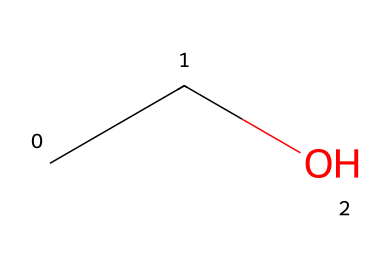What is the name of this chemical? The given SMILES representation "CCO" corresponds to ethanol, a common alcohol. The structure reveals two carbon atoms and one hydroxyl group, which identifies it as ethanol.
Answer: ethanol How many carbon atoms are present in this molecule? By analyzing the SMILES "CCO," we see "CC," which indicates 2 carbon atoms.
Answer: 2 What functional group does this molecule contain? The "O" at the end of "CCO" indicates the presence of a hydroxyl group (-OH), which is characteristic of alcohols like ethanol.
Answer: hydroxyl What is the molecular formula of this compound? From the structure "CCO," we can count 2 carbons (C), 6 hydrogens (H) suggested from the complete structure, and 1 oxygen (O), leading to the molecular formula C2H6O.
Answer: C2H6O What type of bonding is predominantly present in ethanol? Ethanol exhibits covalent bonding, as seen from the connections between carbon, oxygen, and hydrogen atoms in its structure.
Answer: covalent Is this molecule polar or nonpolar? The presence of the hydroxyl group (-OH) introduces a polar feature due to the electronegativity difference between oxygen and hydrogen, making the entire molecule polar.
Answer: polar How many hydrogen atoms are in this molecule? In the SMILES "CCO," there are 6 hydrogen atoms calculated from the overall structure (2 from each carbon and one from the hydroxyl group).
Answer: 6 